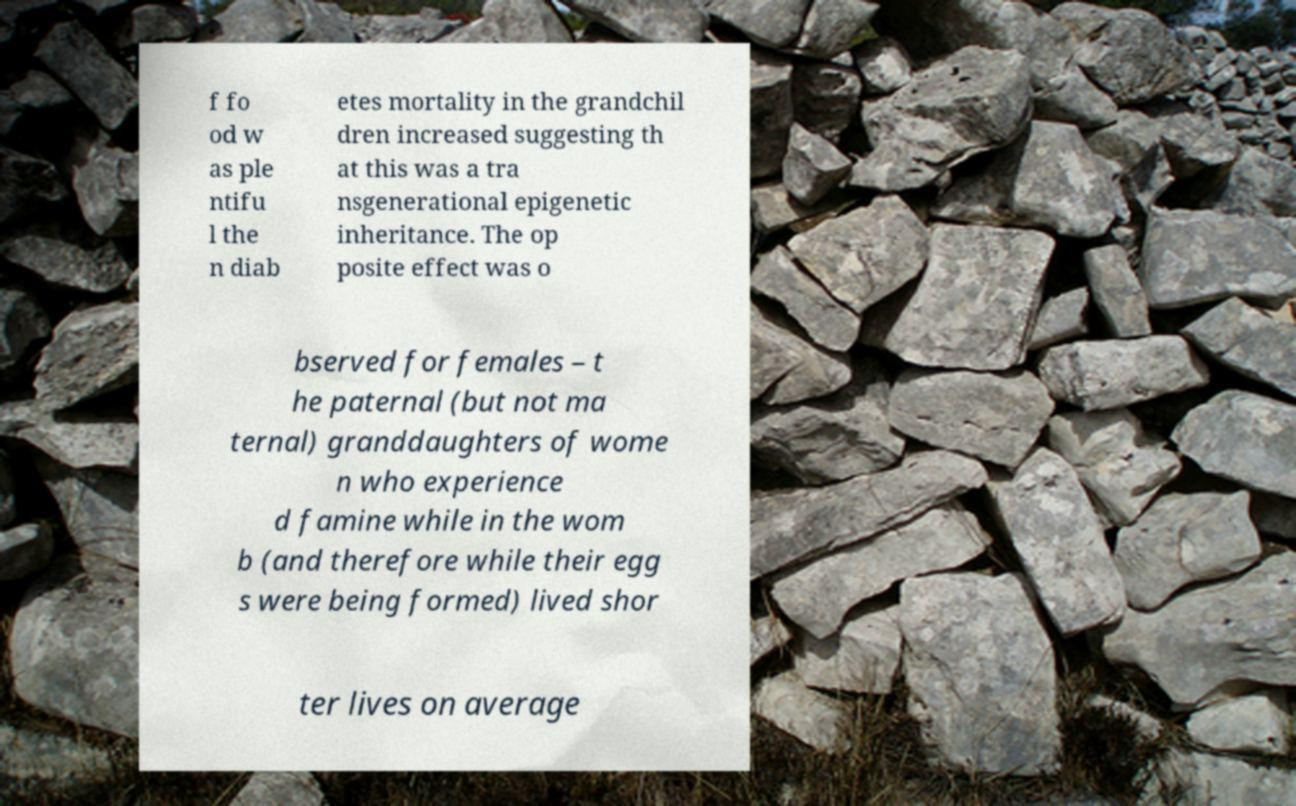What messages or text are displayed in this image? I need them in a readable, typed format. f fo od w as ple ntifu l the n diab etes mortality in the grandchil dren increased suggesting th at this was a tra nsgenerational epigenetic inheritance. The op posite effect was o bserved for females – t he paternal (but not ma ternal) granddaughters of wome n who experience d famine while in the wom b (and therefore while their egg s were being formed) lived shor ter lives on average 